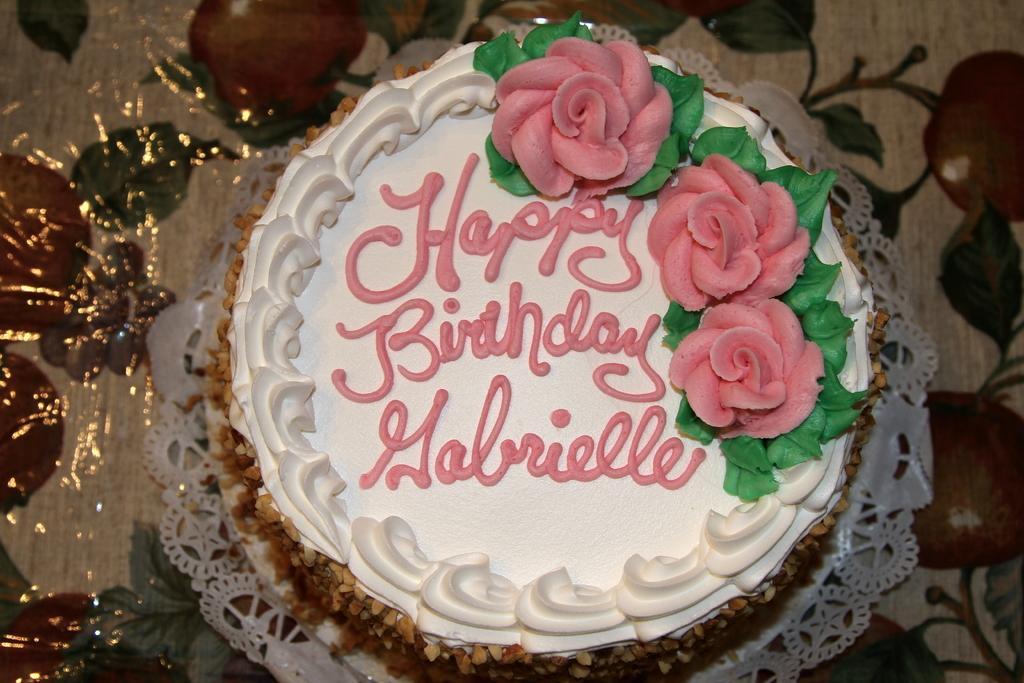Please provide a concise description of this image. In this image I can see a cake is placed on a cloth. On the cake there is some text. 